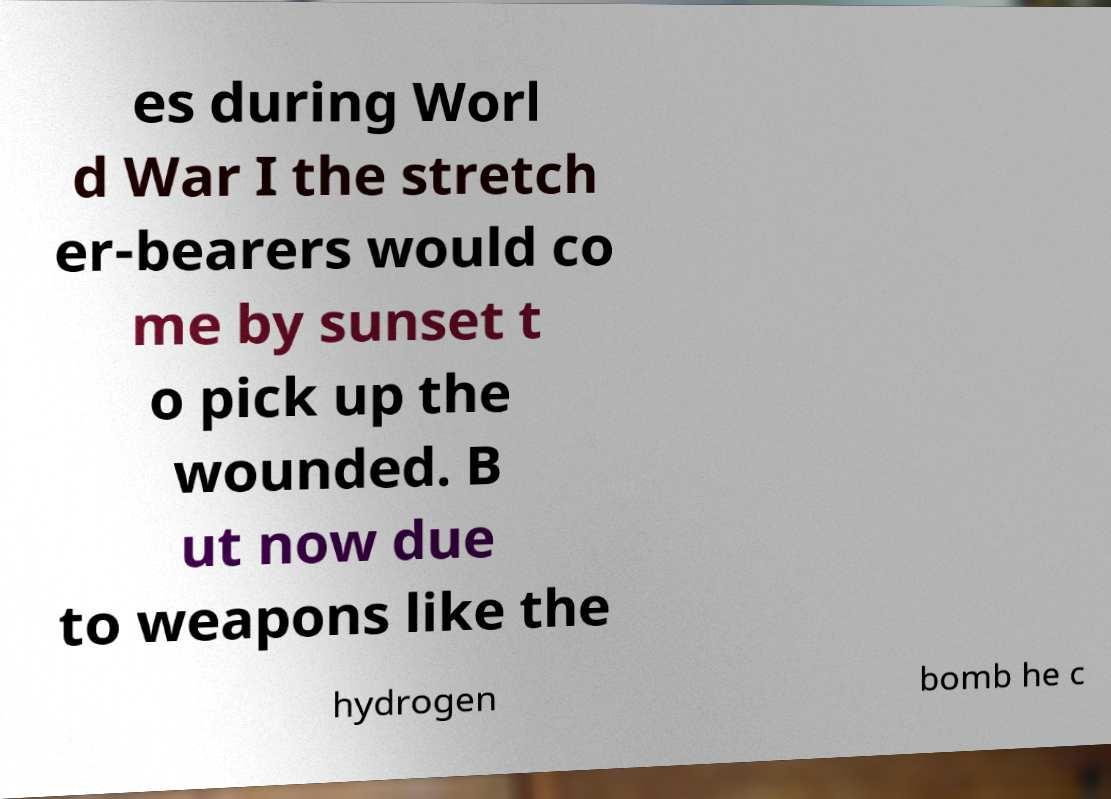Can you accurately transcribe the text from the provided image for me? es during Worl d War I the stretch er-bearers would co me by sunset t o pick up the wounded. B ut now due to weapons like the hydrogen bomb he c 